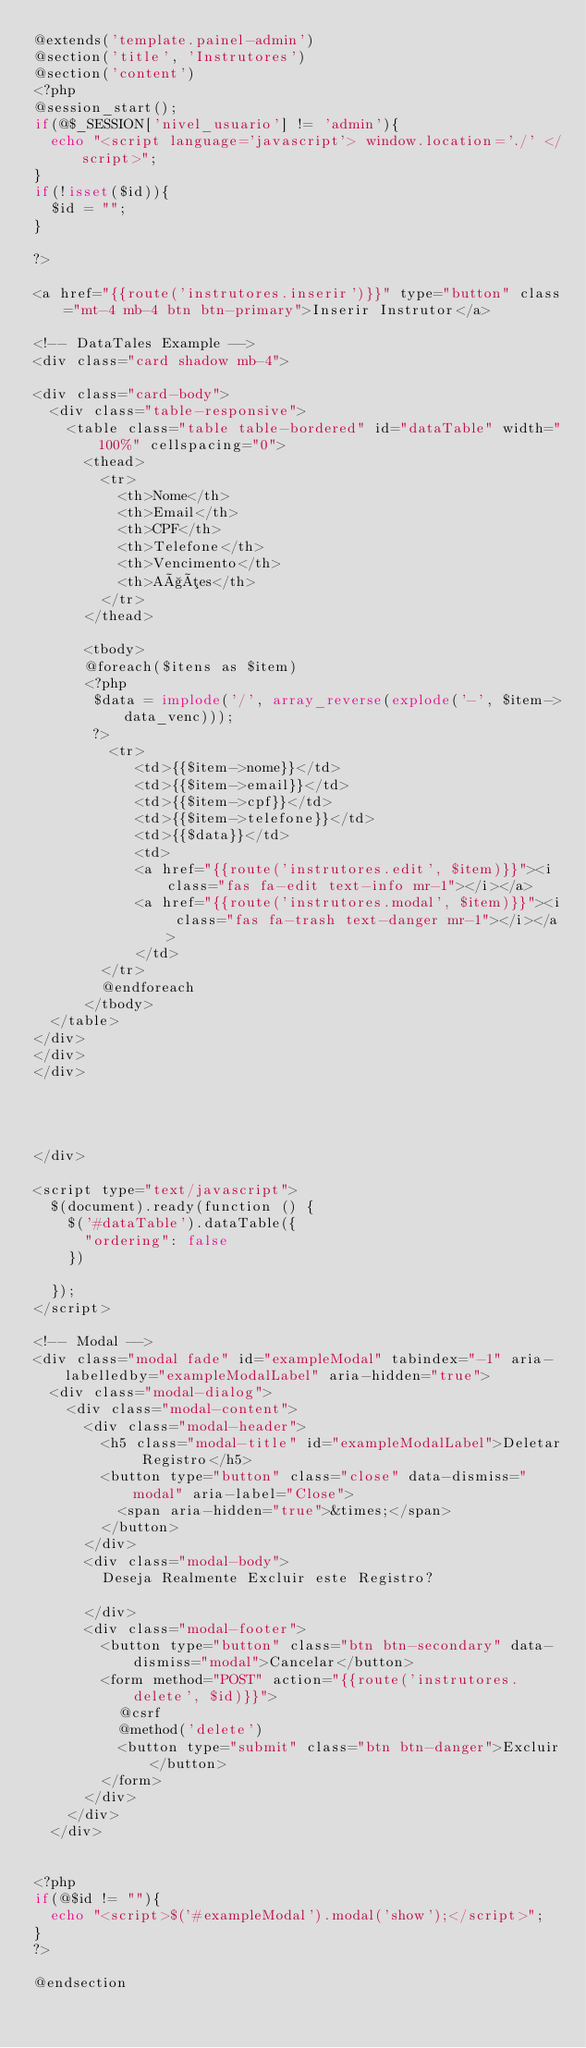Convert code to text. <code><loc_0><loc_0><loc_500><loc_500><_PHP_>@extends('template.painel-admin')
@section('title', 'Instrutores')
@section('content')
<?php 
@session_start();
if(@$_SESSION['nivel_usuario'] != 'admin'){ 
  echo "<script language='javascript'> window.location='./' </script>";
}
if(!isset($id)){
  $id = "";  
}

?>

<a href="{{route('instrutores.inserir')}}" type="button" class="mt-4 mb-4 btn btn-primary">Inserir Instrutor</a>

<!-- DataTales Example -->
<div class="card shadow mb-4">

<div class="card-body">
  <div class="table-responsive">
    <table class="table table-bordered" id="dataTable" width="100%" cellspacing="0">
      <thead>
        <tr>
          <th>Nome</th>
          <th>Email</th>
          <th>CPF</th>
          <th>Telefone</th>
          <th>Vencimento</th>
          <th>Ações</th>
        </tr>
      </thead>

      <tbody>
      @foreach($itens as $item)      
      <?php 
       $data = implode('/', array_reverse(explode('-', $item->data_venc)));
       ?>
         <tr>
            <td>{{$item->nome}}</td>
            <td>{{$item->email}}</td>
            <td>{{$item->cpf}}</td>
            <td>{{$item->telefone}}</td>
            <td>{{$data}}</td>
            <td>
            <a href="{{route('instrutores.edit', $item)}}"><i class="fas fa-edit text-info mr-1"></i></a>
            <a href="{{route('instrutores.modal', $item)}}"><i class="fas fa-trash text-danger mr-1"></i></a>
            </td>
        </tr>
        @endforeach 
      </tbody>
  </table>
</div>
</div>
</div>




</div>

<script type="text/javascript">
  $(document).ready(function () {
    $('#dataTable').dataTable({
      "ordering": false
    })

  });
</script>

<!-- Modal -->
<div class="modal fade" id="exampleModal" tabindex="-1" aria-labelledby="exampleModalLabel" aria-hidden="true">
  <div class="modal-dialog">
    <div class="modal-content">
      <div class="modal-header">
        <h5 class="modal-title" id="exampleModalLabel">Deletar Registro</h5>
        <button type="button" class="close" data-dismiss="modal" aria-label="Close">
          <span aria-hidden="true">&times;</span>
        </button>
      </div>
      <div class="modal-body">
        Deseja Realmente Excluir este Registro?
        
      </div>
      <div class="modal-footer">
        <button type="button" class="btn btn-secondary" data-dismiss="modal">Cancelar</button>
        <form method="POST" action="{{route('instrutores.delete', $id)}}">
          @csrf
          @method('delete')
          <button type="submit" class="btn btn-danger">Excluir</button>
        </form>
      </div>
    </div>
  </div>


<?php 
if(@$id != ""){
  echo "<script>$('#exampleModal').modal('show');</script>";
}
?>

@endsection</code> 